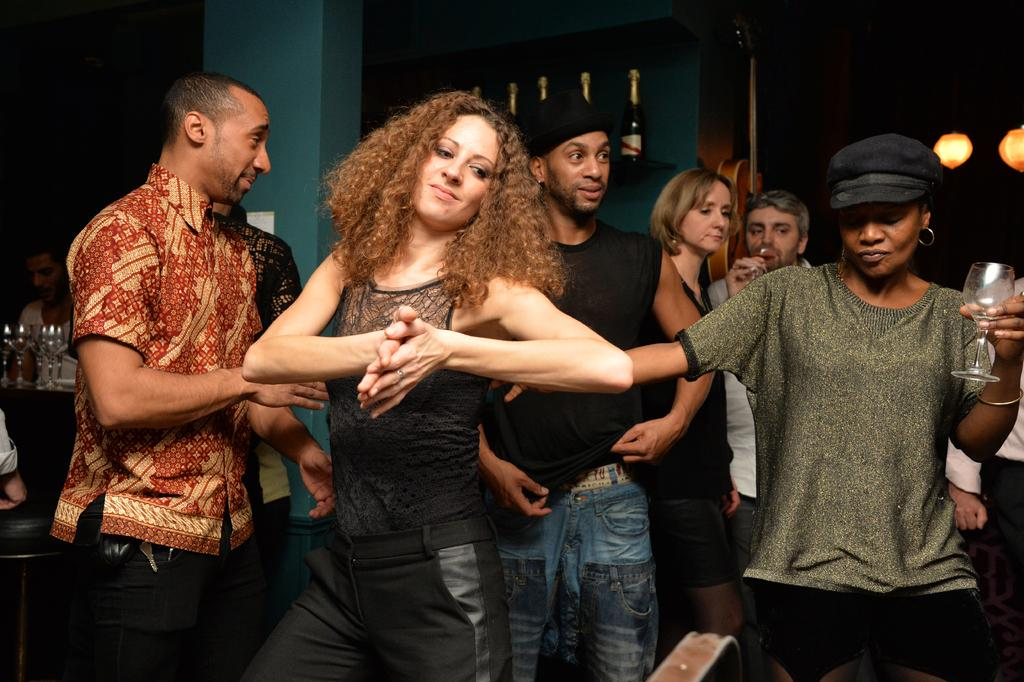What is happening in the image? There are people standing in the image. Can you describe the woman in the image? The woman is holding a wine glass in her hand. Where are the wine bottles located in the image? Wine bottles are present on a rack in the image. What type of metal is used to make the cannon in the image? There is no cannon present in the image. 